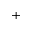Convert formula to latex. <formula><loc_0><loc_0><loc_500><loc_500>+</formula> 